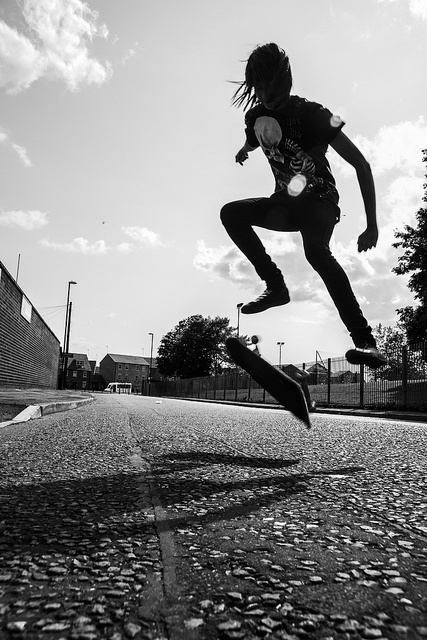Describe the objects in this image and their specific colors. I can see people in gray, black, lightgray, and darkgray tones, skateboard in gray, black, darkgray, and lightgray tones, and truck in gray, black, darkgray, and gainsboro tones in this image. 